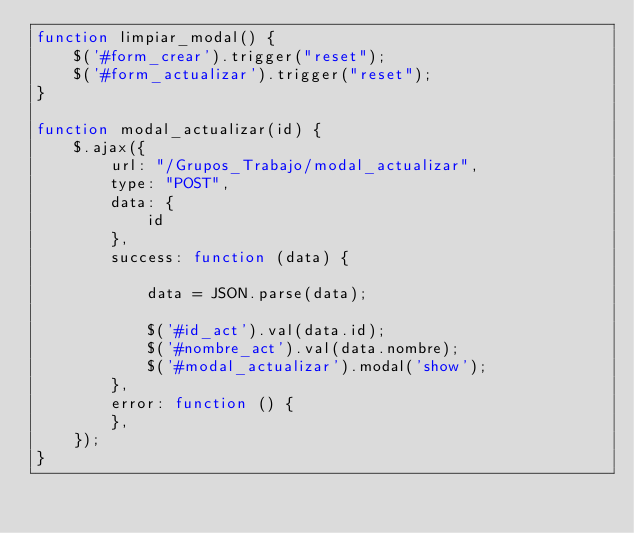<code> <loc_0><loc_0><loc_500><loc_500><_JavaScript_>function limpiar_modal() {
    $('#form_crear').trigger("reset");
    $('#form_actualizar').trigger("reset");
}

function modal_actualizar(id) {
    $.ajax({
        url: "/Grupos_Trabajo/modal_actualizar",
        type: "POST",
        data: {
            id
        },
        success: function (data) {

            data = JSON.parse(data);

            $('#id_act').val(data.id);
            $('#nombre_act').val(data.nombre);
            $('#modal_actualizar').modal('show');
        },
        error: function () {
        },
    });
}


</code> 